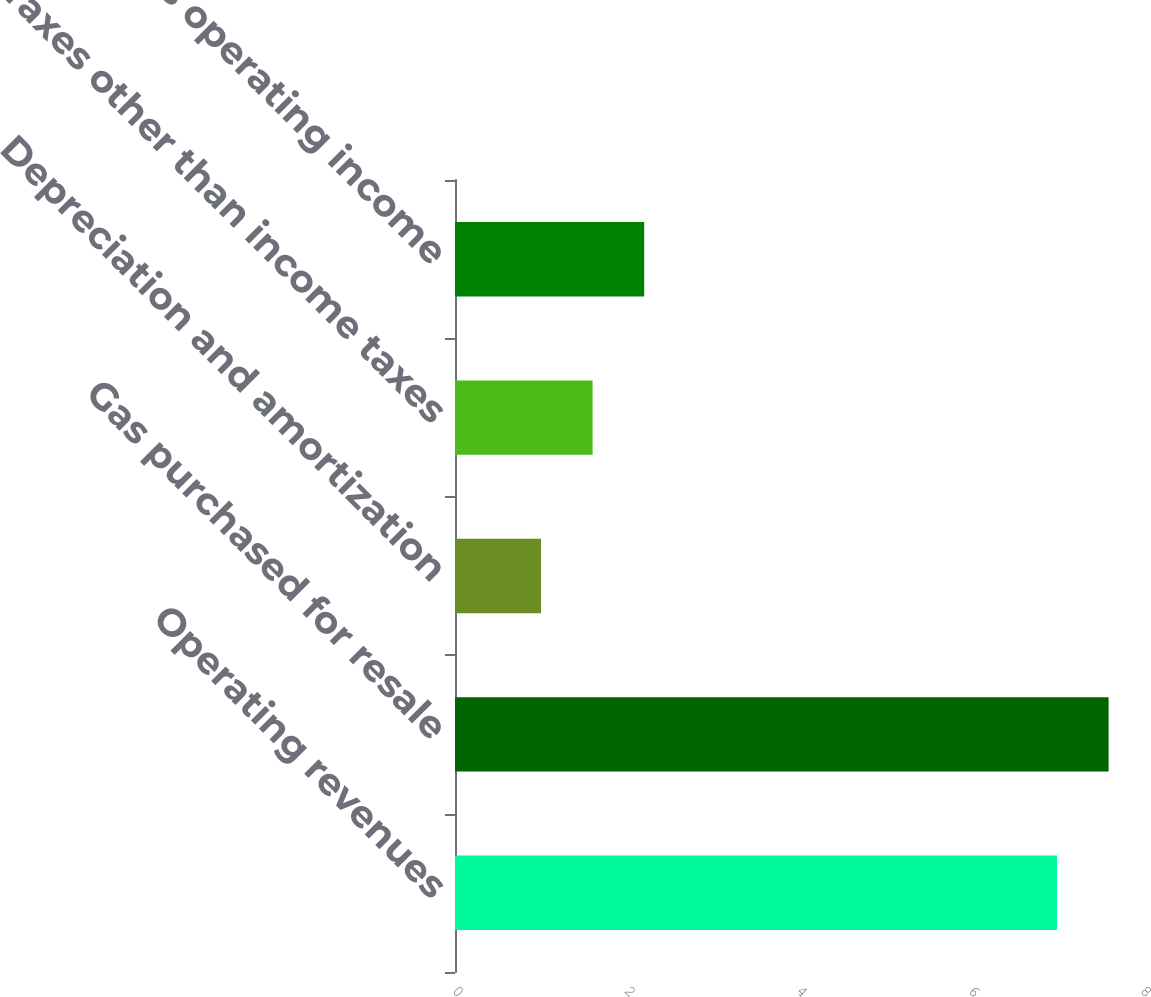Convert chart to OTSL. <chart><loc_0><loc_0><loc_500><loc_500><bar_chart><fcel>Operating revenues<fcel>Gas purchased for resale<fcel>Depreciation and amortization<fcel>Taxes other than income taxes<fcel>Gas operating income<nl><fcel>7<fcel>7.6<fcel>1<fcel>1.6<fcel>2.2<nl></chart> 